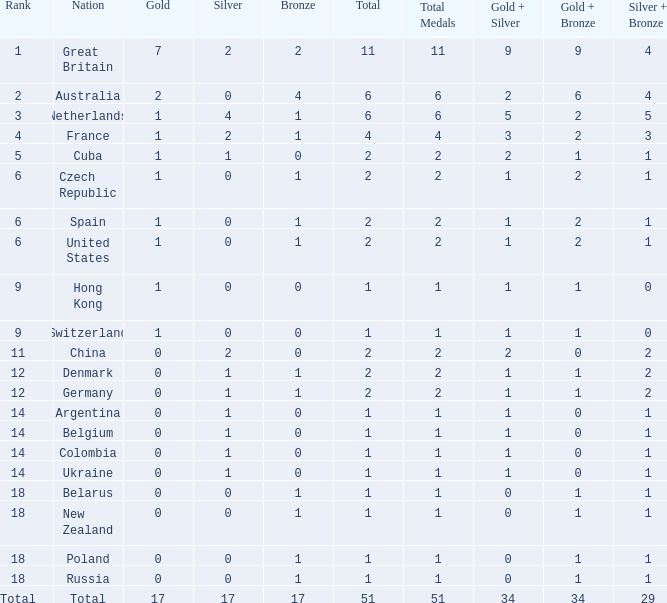Tell me the rank for bronze less than 17 and gold less than 1 11.0. 